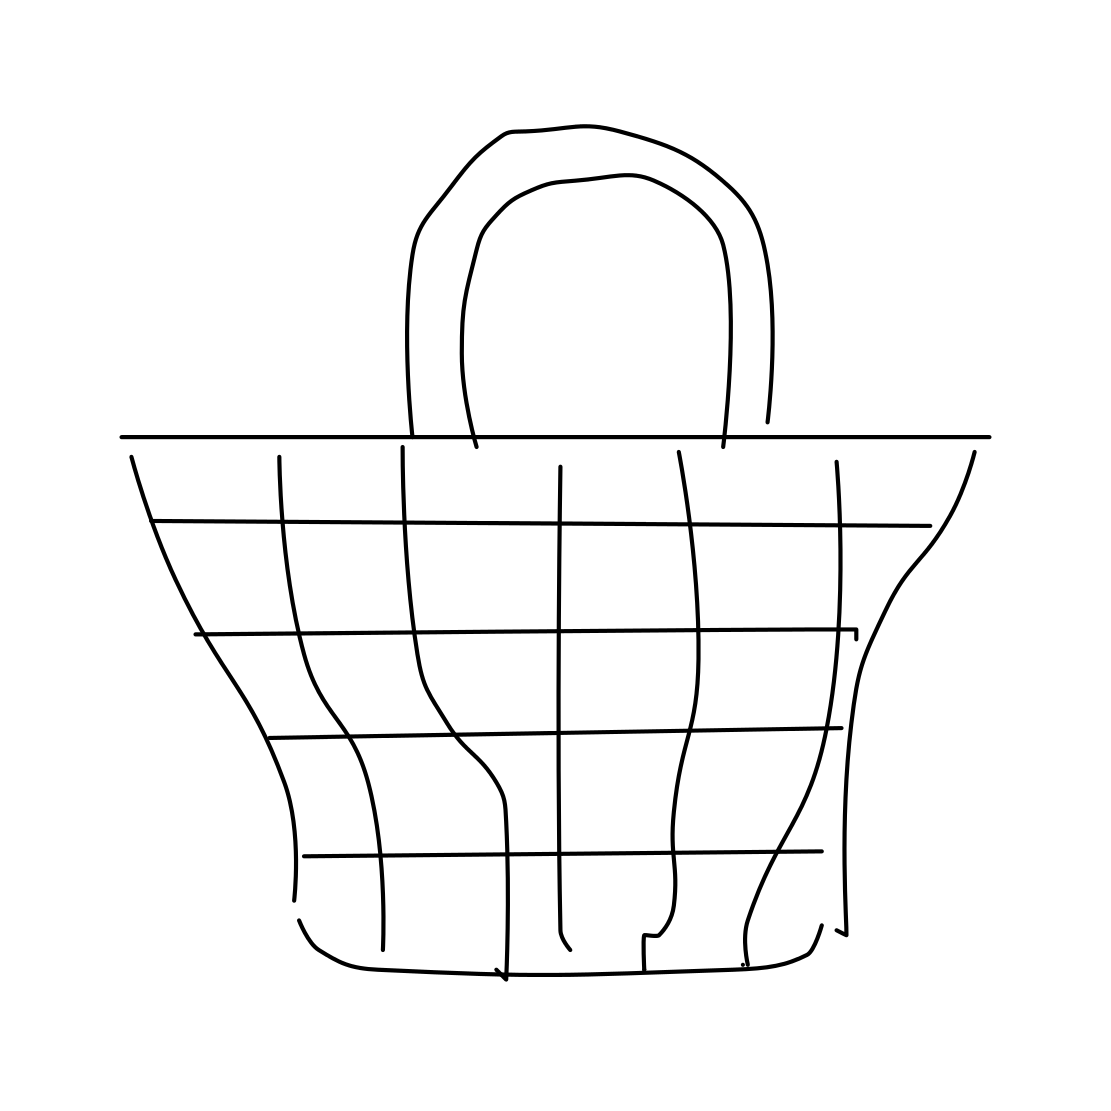What material does this basket seem to be made of in the image? The basket in the image appears to be conceptual and stylized, drawn in a simple, outline form which doesn’t specify a particular material. It's designed with a grid pattern that might suggest flexibility, resembling materials like wire mesh or plastic strips in real life. 